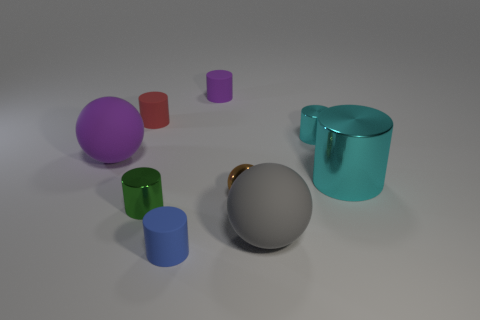There is a red rubber thing; what number of small metal objects are to the right of it?
Keep it short and to the point. 3. Are there any large matte things that have the same color as the big cylinder?
Offer a very short reply. No. What shape is the cyan shiny thing that is the same size as the green shiny cylinder?
Your answer should be very brief. Cylinder. What number of yellow things are either large cylinders or tiny rubber objects?
Offer a very short reply. 0. What number of other matte cylinders are the same size as the green cylinder?
Provide a succinct answer. 3. What is the shape of the object that is the same color as the big metal cylinder?
Provide a short and direct response. Cylinder. What number of things are large blue rubber spheres or small things that are behind the tiny brown ball?
Provide a succinct answer. 3. There is a cyan cylinder behind the large purple rubber object; is it the same size as the cyan shiny cylinder in front of the big purple ball?
Your answer should be very brief. No. How many other blue objects are the same shape as the blue matte thing?
Offer a terse response. 0. What shape is the gray thing that is made of the same material as the big purple ball?
Offer a terse response. Sphere. 